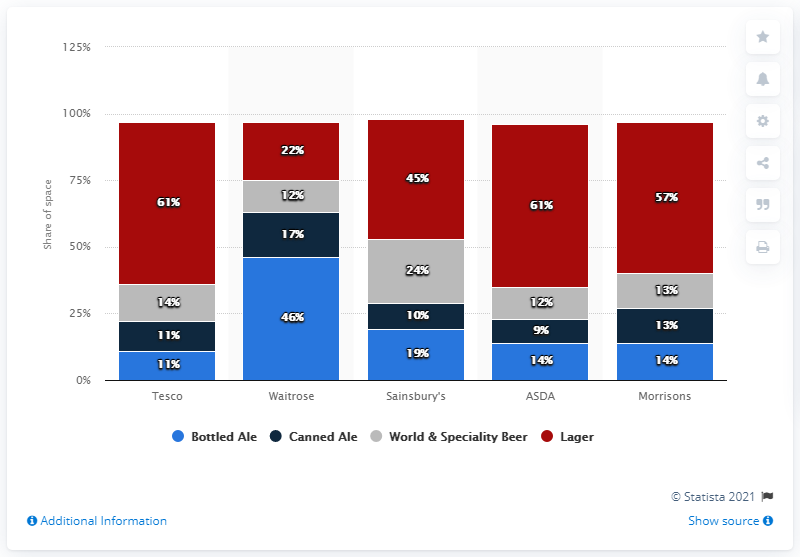Identify some key points in this picture. Waitrose dedicated 46 percent of its beer section to bottled ales. The majority of beer space at Tesco was dedicated to lagers. 